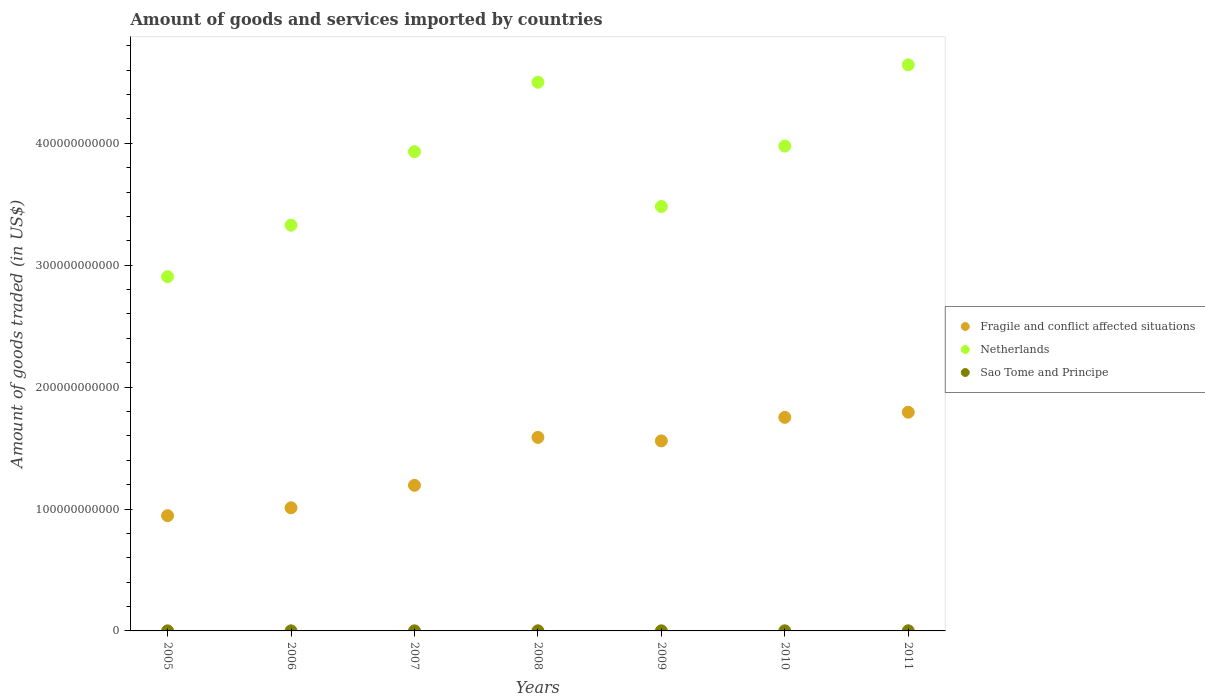Is the number of dotlines equal to the number of legend labels?
Your response must be concise. Yes. What is the total amount of goods and services imported in Fragile and conflict affected situations in 2008?
Ensure brevity in your answer.  1.59e+11. Across all years, what is the maximum total amount of goods and services imported in Netherlands?
Ensure brevity in your answer.  4.64e+11. Across all years, what is the minimum total amount of goods and services imported in Sao Tome and Principe?
Offer a terse response. 4.16e+07. What is the total total amount of goods and services imported in Sao Tome and Principe in the graph?
Provide a short and direct response. 5.54e+08. What is the difference between the total amount of goods and services imported in Sao Tome and Principe in 2008 and that in 2011?
Offer a very short reply. -2.35e+07. What is the difference between the total amount of goods and services imported in Fragile and conflict affected situations in 2009 and the total amount of goods and services imported in Sao Tome and Principe in 2007?
Make the answer very short. 1.56e+11. What is the average total amount of goods and services imported in Netherlands per year?
Give a very brief answer. 3.82e+11. In the year 2005, what is the difference between the total amount of goods and services imported in Fragile and conflict affected situations and total amount of goods and services imported in Sao Tome and Principe?
Keep it short and to the point. 9.45e+1. In how many years, is the total amount of goods and services imported in Fragile and conflict affected situations greater than 200000000000 US$?
Offer a terse response. 0. What is the ratio of the total amount of goods and services imported in Fragile and conflict affected situations in 2009 to that in 2011?
Ensure brevity in your answer.  0.87. Is the difference between the total amount of goods and services imported in Fragile and conflict affected situations in 2006 and 2010 greater than the difference between the total amount of goods and services imported in Sao Tome and Principe in 2006 and 2010?
Provide a short and direct response. No. What is the difference between the highest and the second highest total amount of goods and services imported in Netherlands?
Your answer should be compact. 1.42e+1. What is the difference between the highest and the lowest total amount of goods and services imported in Fragile and conflict affected situations?
Make the answer very short. 8.49e+1. Is the total amount of goods and services imported in Netherlands strictly greater than the total amount of goods and services imported in Fragile and conflict affected situations over the years?
Offer a terse response. Yes. What is the difference between two consecutive major ticks on the Y-axis?
Your answer should be compact. 1.00e+11. Does the graph contain grids?
Make the answer very short. No. Where does the legend appear in the graph?
Your answer should be compact. Center right. How many legend labels are there?
Offer a very short reply. 3. What is the title of the graph?
Offer a very short reply. Amount of goods and services imported by countries. Does "South Asia" appear as one of the legend labels in the graph?
Your response must be concise. No. What is the label or title of the X-axis?
Your response must be concise. Years. What is the label or title of the Y-axis?
Provide a succinct answer. Amount of goods traded (in US$). What is the Amount of goods traded (in US$) of Fragile and conflict affected situations in 2005?
Provide a succinct answer. 9.45e+1. What is the Amount of goods traded (in US$) in Netherlands in 2005?
Keep it short and to the point. 2.91e+11. What is the Amount of goods traded (in US$) in Sao Tome and Principe in 2005?
Your answer should be very brief. 4.16e+07. What is the Amount of goods traded (in US$) of Fragile and conflict affected situations in 2006?
Your answer should be compact. 1.01e+11. What is the Amount of goods traded (in US$) of Netherlands in 2006?
Offer a very short reply. 3.33e+11. What is the Amount of goods traded (in US$) in Sao Tome and Principe in 2006?
Ensure brevity in your answer.  5.92e+07. What is the Amount of goods traded (in US$) of Fragile and conflict affected situations in 2007?
Provide a short and direct response. 1.19e+11. What is the Amount of goods traded (in US$) in Netherlands in 2007?
Provide a short and direct response. 3.93e+11. What is the Amount of goods traded (in US$) in Sao Tome and Principe in 2007?
Keep it short and to the point. 6.49e+07. What is the Amount of goods traded (in US$) of Fragile and conflict affected situations in 2008?
Your answer should be very brief. 1.59e+11. What is the Amount of goods traded (in US$) of Netherlands in 2008?
Your answer should be compact. 4.50e+11. What is the Amount of goods traded (in US$) of Sao Tome and Principe in 2008?
Make the answer very short. 9.22e+07. What is the Amount of goods traded (in US$) in Fragile and conflict affected situations in 2009?
Offer a very short reply. 1.56e+11. What is the Amount of goods traded (in US$) in Netherlands in 2009?
Make the answer very short. 3.48e+11. What is the Amount of goods traded (in US$) in Sao Tome and Principe in 2009?
Your response must be concise. 8.38e+07. What is the Amount of goods traded (in US$) in Fragile and conflict affected situations in 2010?
Provide a succinct answer. 1.75e+11. What is the Amount of goods traded (in US$) of Netherlands in 2010?
Make the answer very short. 3.98e+11. What is the Amount of goods traded (in US$) of Sao Tome and Principe in 2010?
Ensure brevity in your answer.  9.62e+07. What is the Amount of goods traded (in US$) in Fragile and conflict affected situations in 2011?
Your answer should be compact. 1.79e+11. What is the Amount of goods traded (in US$) in Netherlands in 2011?
Your response must be concise. 4.64e+11. What is the Amount of goods traded (in US$) of Sao Tome and Principe in 2011?
Ensure brevity in your answer.  1.16e+08. Across all years, what is the maximum Amount of goods traded (in US$) in Fragile and conflict affected situations?
Give a very brief answer. 1.79e+11. Across all years, what is the maximum Amount of goods traded (in US$) in Netherlands?
Offer a terse response. 4.64e+11. Across all years, what is the maximum Amount of goods traded (in US$) in Sao Tome and Principe?
Provide a short and direct response. 1.16e+08. Across all years, what is the minimum Amount of goods traded (in US$) of Fragile and conflict affected situations?
Provide a short and direct response. 9.45e+1. Across all years, what is the minimum Amount of goods traded (in US$) of Netherlands?
Provide a short and direct response. 2.91e+11. Across all years, what is the minimum Amount of goods traded (in US$) of Sao Tome and Principe?
Make the answer very short. 4.16e+07. What is the total Amount of goods traded (in US$) of Fragile and conflict affected situations in the graph?
Provide a succinct answer. 9.84e+11. What is the total Amount of goods traded (in US$) of Netherlands in the graph?
Your answer should be very brief. 2.68e+12. What is the total Amount of goods traded (in US$) in Sao Tome and Principe in the graph?
Make the answer very short. 5.54e+08. What is the difference between the Amount of goods traded (in US$) of Fragile and conflict affected situations in 2005 and that in 2006?
Provide a short and direct response. -6.45e+09. What is the difference between the Amount of goods traded (in US$) of Netherlands in 2005 and that in 2006?
Your response must be concise. -4.23e+1. What is the difference between the Amount of goods traded (in US$) in Sao Tome and Principe in 2005 and that in 2006?
Offer a terse response. -1.76e+07. What is the difference between the Amount of goods traded (in US$) of Fragile and conflict affected situations in 2005 and that in 2007?
Offer a very short reply. -2.49e+1. What is the difference between the Amount of goods traded (in US$) in Netherlands in 2005 and that in 2007?
Give a very brief answer. -1.03e+11. What is the difference between the Amount of goods traded (in US$) of Sao Tome and Principe in 2005 and that in 2007?
Your answer should be very brief. -2.33e+07. What is the difference between the Amount of goods traded (in US$) of Fragile and conflict affected situations in 2005 and that in 2008?
Ensure brevity in your answer.  -6.42e+1. What is the difference between the Amount of goods traded (in US$) in Netherlands in 2005 and that in 2008?
Provide a short and direct response. -1.60e+11. What is the difference between the Amount of goods traded (in US$) in Sao Tome and Principe in 2005 and that in 2008?
Your response must be concise. -5.06e+07. What is the difference between the Amount of goods traded (in US$) in Fragile and conflict affected situations in 2005 and that in 2009?
Offer a very short reply. -6.14e+1. What is the difference between the Amount of goods traded (in US$) of Netherlands in 2005 and that in 2009?
Provide a succinct answer. -5.76e+1. What is the difference between the Amount of goods traded (in US$) in Sao Tome and Principe in 2005 and that in 2009?
Keep it short and to the point. -4.22e+07. What is the difference between the Amount of goods traded (in US$) in Fragile and conflict affected situations in 2005 and that in 2010?
Your answer should be very brief. -8.07e+1. What is the difference between the Amount of goods traded (in US$) in Netherlands in 2005 and that in 2010?
Make the answer very short. -1.07e+11. What is the difference between the Amount of goods traded (in US$) in Sao Tome and Principe in 2005 and that in 2010?
Provide a short and direct response. -5.46e+07. What is the difference between the Amount of goods traded (in US$) of Fragile and conflict affected situations in 2005 and that in 2011?
Provide a short and direct response. -8.49e+1. What is the difference between the Amount of goods traded (in US$) of Netherlands in 2005 and that in 2011?
Offer a very short reply. -1.74e+11. What is the difference between the Amount of goods traded (in US$) in Sao Tome and Principe in 2005 and that in 2011?
Your answer should be very brief. -7.41e+07. What is the difference between the Amount of goods traded (in US$) in Fragile and conflict affected situations in 2006 and that in 2007?
Provide a succinct answer. -1.84e+1. What is the difference between the Amount of goods traded (in US$) of Netherlands in 2006 and that in 2007?
Offer a terse response. -6.03e+1. What is the difference between the Amount of goods traded (in US$) in Sao Tome and Principe in 2006 and that in 2007?
Your answer should be very brief. -5.63e+06. What is the difference between the Amount of goods traded (in US$) of Fragile and conflict affected situations in 2006 and that in 2008?
Keep it short and to the point. -5.78e+1. What is the difference between the Amount of goods traded (in US$) in Netherlands in 2006 and that in 2008?
Keep it short and to the point. -1.17e+11. What is the difference between the Amount of goods traded (in US$) in Sao Tome and Principe in 2006 and that in 2008?
Provide a succinct answer. -3.29e+07. What is the difference between the Amount of goods traded (in US$) of Fragile and conflict affected situations in 2006 and that in 2009?
Provide a short and direct response. -5.49e+1. What is the difference between the Amount of goods traded (in US$) in Netherlands in 2006 and that in 2009?
Offer a very short reply. -1.53e+1. What is the difference between the Amount of goods traded (in US$) in Sao Tome and Principe in 2006 and that in 2009?
Your answer should be very brief. -2.45e+07. What is the difference between the Amount of goods traded (in US$) in Fragile and conflict affected situations in 2006 and that in 2010?
Your answer should be compact. -7.42e+1. What is the difference between the Amount of goods traded (in US$) in Netherlands in 2006 and that in 2010?
Provide a succinct answer. -6.49e+1. What is the difference between the Amount of goods traded (in US$) in Sao Tome and Principe in 2006 and that in 2010?
Give a very brief answer. -3.70e+07. What is the difference between the Amount of goods traded (in US$) in Fragile and conflict affected situations in 2006 and that in 2011?
Ensure brevity in your answer.  -7.84e+1. What is the difference between the Amount of goods traded (in US$) of Netherlands in 2006 and that in 2011?
Offer a terse response. -1.32e+11. What is the difference between the Amount of goods traded (in US$) of Sao Tome and Principe in 2006 and that in 2011?
Offer a very short reply. -5.64e+07. What is the difference between the Amount of goods traded (in US$) in Fragile and conflict affected situations in 2007 and that in 2008?
Ensure brevity in your answer.  -3.93e+1. What is the difference between the Amount of goods traded (in US$) in Netherlands in 2007 and that in 2008?
Offer a terse response. -5.70e+1. What is the difference between the Amount of goods traded (in US$) of Sao Tome and Principe in 2007 and that in 2008?
Your answer should be very brief. -2.73e+07. What is the difference between the Amount of goods traded (in US$) in Fragile and conflict affected situations in 2007 and that in 2009?
Provide a short and direct response. -3.65e+1. What is the difference between the Amount of goods traded (in US$) of Netherlands in 2007 and that in 2009?
Offer a terse response. 4.50e+1. What is the difference between the Amount of goods traded (in US$) of Sao Tome and Principe in 2007 and that in 2009?
Make the answer very short. -1.89e+07. What is the difference between the Amount of goods traded (in US$) of Fragile and conflict affected situations in 2007 and that in 2010?
Keep it short and to the point. -5.58e+1. What is the difference between the Amount of goods traded (in US$) in Netherlands in 2007 and that in 2010?
Your response must be concise. -4.58e+09. What is the difference between the Amount of goods traded (in US$) of Sao Tome and Principe in 2007 and that in 2010?
Ensure brevity in your answer.  -3.13e+07. What is the difference between the Amount of goods traded (in US$) of Fragile and conflict affected situations in 2007 and that in 2011?
Ensure brevity in your answer.  -6.00e+1. What is the difference between the Amount of goods traded (in US$) of Netherlands in 2007 and that in 2011?
Give a very brief answer. -7.12e+1. What is the difference between the Amount of goods traded (in US$) of Sao Tome and Principe in 2007 and that in 2011?
Ensure brevity in your answer.  -5.08e+07. What is the difference between the Amount of goods traded (in US$) of Fragile and conflict affected situations in 2008 and that in 2009?
Offer a terse response. 2.86e+09. What is the difference between the Amount of goods traded (in US$) in Netherlands in 2008 and that in 2009?
Provide a short and direct response. 1.02e+11. What is the difference between the Amount of goods traded (in US$) of Sao Tome and Principe in 2008 and that in 2009?
Your response must be concise. 8.39e+06. What is the difference between the Amount of goods traded (in US$) of Fragile and conflict affected situations in 2008 and that in 2010?
Offer a terse response. -1.64e+1. What is the difference between the Amount of goods traded (in US$) in Netherlands in 2008 and that in 2010?
Make the answer very short. 5.24e+1. What is the difference between the Amount of goods traded (in US$) of Sao Tome and Principe in 2008 and that in 2010?
Your answer should be very brief. -4.04e+06. What is the difference between the Amount of goods traded (in US$) of Fragile and conflict affected situations in 2008 and that in 2011?
Offer a terse response. -2.06e+1. What is the difference between the Amount of goods traded (in US$) in Netherlands in 2008 and that in 2011?
Give a very brief answer. -1.42e+1. What is the difference between the Amount of goods traded (in US$) of Sao Tome and Principe in 2008 and that in 2011?
Provide a short and direct response. -2.35e+07. What is the difference between the Amount of goods traded (in US$) of Fragile and conflict affected situations in 2009 and that in 2010?
Keep it short and to the point. -1.93e+1. What is the difference between the Amount of goods traded (in US$) in Netherlands in 2009 and that in 2010?
Provide a succinct answer. -4.96e+1. What is the difference between the Amount of goods traded (in US$) of Sao Tome and Principe in 2009 and that in 2010?
Your answer should be very brief. -1.24e+07. What is the difference between the Amount of goods traded (in US$) in Fragile and conflict affected situations in 2009 and that in 2011?
Offer a terse response. -2.35e+1. What is the difference between the Amount of goods traded (in US$) of Netherlands in 2009 and that in 2011?
Offer a very short reply. -1.16e+11. What is the difference between the Amount of goods traded (in US$) in Sao Tome and Principe in 2009 and that in 2011?
Provide a succinct answer. -3.19e+07. What is the difference between the Amount of goods traded (in US$) in Fragile and conflict affected situations in 2010 and that in 2011?
Make the answer very short. -4.21e+09. What is the difference between the Amount of goods traded (in US$) in Netherlands in 2010 and that in 2011?
Offer a very short reply. -6.66e+1. What is the difference between the Amount of goods traded (in US$) in Sao Tome and Principe in 2010 and that in 2011?
Keep it short and to the point. -1.95e+07. What is the difference between the Amount of goods traded (in US$) of Fragile and conflict affected situations in 2005 and the Amount of goods traded (in US$) of Netherlands in 2006?
Provide a succinct answer. -2.38e+11. What is the difference between the Amount of goods traded (in US$) of Fragile and conflict affected situations in 2005 and the Amount of goods traded (in US$) of Sao Tome and Principe in 2006?
Ensure brevity in your answer.  9.45e+1. What is the difference between the Amount of goods traded (in US$) in Netherlands in 2005 and the Amount of goods traded (in US$) in Sao Tome and Principe in 2006?
Your response must be concise. 2.91e+11. What is the difference between the Amount of goods traded (in US$) of Fragile and conflict affected situations in 2005 and the Amount of goods traded (in US$) of Netherlands in 2007?
Provide a short and direct response. -2.99e+11. What is the difference between the Amount of goods traded (in US$) in Fragile and conflict affected situations in 2005 and the Amount of goods traded (in US$) in Sao Tome and Principe in 2007?
Provide a succinct answer. 9.45e+1. What is the difference between the Amount of goods traded (in US$) in Netherlands in 2005 and the Amount of goods traded (in US$) in Sao Tome and Principe in 2007?
Make the answer very short. 2.91e+11. What is the difference between the Amount of goods traded (in US$) in Fragile and conflict affected situations in 2005 and the Amount of goods traded (in US$) in Netherlands in 2008?
Offer a very short reply. -3.56e+11. What is the difference between the Amount of goods traded (in US$) of Fragile and conflict affected situations in 2005 and the Amount of goods traded (in US$) of Sao Tome and Principe in 2008?
Offer a very short reply. 9.44e+1. What is the difference between the Amount of goods traded (in US$) of Netherlands in 2005 and the Amount of goods traded (in US$) of Sao Tome and Principe in 2008?
Provide a succinct answer. 2.90e+11. What is the difference between the Amount of goods traded (in US$) of Fragile and conflict affected situations in 2005 and the Amount of goods traded (in US$) of Netherlands in 2009?
Provide a short and direct response. -2.54e+11. What is the difference between the Amount of goods traded (in US$) in Fragile and conflict affected situations in 2005 and the Amount of goods traded (in US$) in Sao Tome and Principe in 2009?
Give a very brief answer. 9.45e+1. What is the difference between the Amount of goods traded (in US$) in Netherlands in 2005 and the Amount of goods traded (in US$) in Sao Tome and Principe in 2009?
Your answer should be compact. 2.90e+11. What is the difference between the Amount of goods traded (in US$) in Fragile and conflict affected situations in 2005 and the Amount of goods traded (in US$) in Netherlands in 2010?
Your answer should be compact. -3.03e+11. What is the difference between the Amount of goods traded (in US$) of Fragile and conflict affected situations in 2005 and the Amount of goods traded (in US$) of Sao Tome and Principe in 2010?
Ensure brevity in your answer.  9.44e+1. What is the difference between the Amount of goods traded (in US$) in Netherlands in 2005 and the Amount of goods traded (in US$) in Sao Tome and Principe in 2010?
Your answer should be compact. 2.90e+11. What is the difference between the Amount of goods traded (in US$) of Fragile and conflict affected situations in 2005 and the Amount of goods traded (in US$) of Netherlands in 2011?
Make the answer very short. -3.70e+11. What is the difference between the Amount of goods traded (in US$) of Fragile and conflict affected situations in 2005 and the Amount of goods traded (in US$) of Sao Tome and Principe in 2011?
Offer a terse response. 9.44e+1. What is the difference between the Amount of goods traded (in US$) of Netherlands in 2005 and the Amount of goods traded (in US$) of Sao Tome and Principe in 2011?
Keep it short and to the point. 2.90e+11. What is the difference between the Amount of goods traded (in US$) of Fragile and conflict affected situations in 2006 and the Amount of goods traded (in US$) of Netherlands in 2007?
Give a very brief answer. -2.92e+11. What is the difference between the Amount of goods traded (in US$) in Fragile and conflict affected situations in 2006 and the Amount of goods traded (in US$) in Sao Tome and Principe in 2007?
Make the answer very short. 1.01e+11. What is the difference between the Amount of goods traded (in US$) of Netherlands in 2006 and the Amount of goods traded (in US$) of Sao Tome and Principe in 2007?
Offer a terse response. 3.33e+11. What is the difference between the Amount of goods traded (in US$) of Fragile and conflict affected situations in 2006 and the Amount of goods traded (in US$) of Netherlands in 2008?
Keep it short and to the point. -3.49e+11. What is the difference between the Amount of goods traded (in US$) of Fragile and conflict affected situations in 2006 and the Amount of goods traded (in US$) of Sao Tome and Principe in 2008?
Ensure brevity in your answer.  1.01e+11. What is the difference between the Amount of goods traded (in US$) in Netherlands in 2006 and the Amount of goods traded (in US$) in Sao Tome and Principe in 2008?
Your answer should be very brief. 3.33e+11. What is the difference between the Amount of goods traded (in US$) in Fragile and conflict affected situations in 2006 and the Amount of goods traded (in US$) in Netherlands in 2009?
Give a very brief answer. -2.47e+11. What is the difference between the Amount of goods traded (in US$) of Fragile and conflict affected situations in 2006 and the Amount of goods traded (in US$) of Sao Tome and Principe in 2009?
Your response must be concise. 1.01e+11. What is the difference between the Amount of goods traded (in US$) of Netherlands in 2006 and the Amount of goods traded (in US$) of Sao Tome and Principe in 2009?
Your response must be concise. 3.33e+11. What is the difference between the Amount of goods traded (in US$) in Fragile and conflict affected situations in 2006 and the Amount of goods traded (in US$) in Netherlands in 2010?
Provide a short and direct response. -2.97e+11. What is the difference between the Amount of goods traded (in US$) of Fragile and conflict affected situations in 2006 and the Amount of goods traded (in US$) of Sao Tome and Principe in 2010?
Provide a succinct answer. 1.01e+11. What is the difference between the Amount of goods traded (in US$) of Netherlands in 2006 and the Amount of goods traded (in US$) of Sao Tome and Principe in 2010?
Provide a succinct answer. 3.33e+11. What is the difference between the Amount of goods traded (in US$) of Fragile and conflict affected situations in 2006 and the Amount of goods traded (in US$) of Netherlands in 2011?
Provide a short and direct response. -3.63e+11. What is the difference between the Amount of goods traded (in US$) of Fragile and conflict affected situations in 2006 and the Amount of goods traded (in US$) of Sao Tome and Principe in 2011?
Give a very brief answer. 1.01e+11. What is the difference between the Amount of goods traded (in US$) in Netherlands in 2006 and the Amount of goods traded (in US$) in Sao Tome and Principe in 2011?
Your answer should be compact. 3.33e+11. What is the difference between the Amount of goods traded (in US$) in Fragile and conflict affected situations in 2007 and the Amount of goods traded (in US$) in Netherlands in 2008?
Your answer should be very brief. -3.31e+11. What is the difference between the Amount of goods traded (in US$) in Fragile and conflict affected situations in 2007 and the Amount of goods traded (in US$) in Sao Tome and Principe in 2008?
Offer a very short reply. 1.19e+11. What is the difference between the Amount of goods traded (in US$) of Netherlands in 2007 and the Amount of goods traded (in US$) of Sao Tome and Principe in 2008?
Offer a terse response. 3.93e+11. What is the difference between the Amount of goods traded (in US$) of Fragile and conflict affected situations in 2007 and the Amount of goods traded (in US$) of Netherlands in 2009?
Offer a terse response. -2.29e+11. What is the difference between the Amount of goods traded (in US$) of Fragile and conflict affected situations in 2007 and the Amount of goods traded (in US$) of Sao Tome and Principe in 2009?
Provide a short and direct response. 1.19e+11. What is the difference between the Amount of goods traded (in US$) in Netherlands in 2007 and the Amount of goods traded (in US$) in Sao Tome and Principe in 2009?
Provide a short and direct response. 3.93e+11. What is the difference between the Amount of goods traded (in US$) in Fragile and conflict affected situations in 2007 and the Amount of goods traded (in US$) in Netherlands in 2010?
Give a very brief answer. -2.78e+11. What is the difference between the Amount of goods traded (in US$) of Fragile and conflict affected situations in 2007 and the Amount of goods traded (in US$) of Sao Tome and Principe in 2010?
Keep it short and to the point. 1.19e+11. What is the difference between the Amount of goods traded (in US$) in Netherlands in 2007 and the Amount of goods traded (in US$) in Sao Tome and Principe in 2010?
Offer a very short reply. 3.93e+11. What is the difference between the Amount of goods traded (in US$) in Fragile and conflict affected situations in 2007 and the Amount of goods traded (in US$) in Netherlands in 2011?
Give a very brief answer. -3.45e+11. What is the difference between the Amount of goods traded (in US$) in Fragile and conflict affected situations in 2007 and the Amount of goods traded (in US$) in Sao Tome and Principe in 2011?
Provide a succinct answer. 1.19e+11. What is the difference between the Amount of goods traded (in US$) of Netherlands in 2007 and the Amount of goods traded (in US$) of Sao Tome and Principe in 2011?
Provide a short and direct response. 3.93e+11. What is the difference between the Amount of goods traded (in US$) in Fragile and conflict affected situations in 2008 and the Amount of goods traded (in US$) in Netherlands in 2009?
Your answer should be very brief. -1.89e+11. What is the difference between the Amount of goods traded (in US$) in Fragile and conflict affected situations in 2008 and the Amount of goods traded (in US$) in Sao Tome and Principe in 2009?
Offer a very short reply. 1.59e+11. What is the difference between the Amount of goods traded (in US$) of Netherlands in 2008 and the Amount of goods traded (in US$) of Sao Tome and Principe in 2009?
Offer a terse response. 4.50e+11. What is the difference between the Amount of goods traded (in US$) of Fragile and conflict affected situations in 2008 and the Amount of goods traded (in US$) of Netherlands in 2010?
Give a very brief answer. -2.39e+11. What is the difference between the Amount of goods traded (in US$) of Fragile and conflict affected situations in 2008 and the Amount of goods traded (in US$) of Sao Tome and Principe in 2010?
Ensure brevity in your answer.  1.59e+11. What is the difference between the Amount of goods traded (in US$) of Netherlands in 2008 and the Amount of goods traded (in US$) of Sao Tome and Principe in 2010?
Keep it short and to the point. 4.50e+11. What is the difference between the Amount of goods traded (in US$) of Fragile and conflict affected situations in 2008 and the Amount of goods traded (in US$) of Netherlands in 2011?
Offer a very short reply. -3.06e+11. What is the difference between the Amount of goods traded (in US$) in Fragile and conflict affected situations in 2008 and the Amount of goods traded (in US$) in Sao Tome and Principe in 2011?
Your answer should be compact. 1.59e+11. What is the difference between the Amount of goods traded (in US$) of Netherlands in 2008 and the Amount of goods traded (in US$) of Sao Tome and Principe in 2011?
Make the answer very short. 4.50e+11. What is the difference between the Amount of goods traded (in US$) of Fragile and conflict affected situations in 2009 and the Amount of goods traded (in US$) of Netherlands in 2010?
Make the answer very short. -2.42e+11. What is the difference between the Amount of goods traded (in US$) of Fragile and conflict affected situations in 2009 and the Amount of goods traded (in US$) of Sao Tome and Principe in 2010?
Your response must be concise. 1.56e+11. What is the difference between the Amount of goods traded (in US$) in Netherlands in 2009 and the Amount of goods traded (in US$) in Sao Tome and Principe in 2010?
Make the answer very short. 3.48e+11. What is the difference between the Amount of goods traded (in US$) of Fragile and conflict affected situations in 2009 and the Amount of goods traded (in US$) of Netherlands in 2011?
Ensure brevity in your answer.  -3.08e+11. What is the difference between the Amount of goods traded (in US$) of Fragile and conflict affected situations in 2009 and the Amount of goods traded (in US$) of Sao Tome and Principe in 2011?
Keep it short and to the point. 1.56e+11. What is the difference between the Amount of goods traded (in US$) of Netherlands in 2009 and the Amount of goods traded (in US$) of Sao Tome and Principe in 2011?
Offer a very short reply. 3.48e+11. What is the difference between the Amount of goods traded (in US$) of Fragile and conflict affected situations in 2010 and the Amount of goods traded (in US$) of Netherlands in 2011?
Your answer should be very brief. -2.89e+11. What is the difference between the Amount of goods traded (in US$) of Fragile and conflict affected situations in 2010 and the Amount of goods traded (in US$) of Sao Tome and Principe in 2011?
Make the answer very short. 1.75e+11. What is the difference between the Amount of goods traded (in US$) in Netherlands in 2010 and the Amount of goods traded (in US$) in Sao Tome and Principe in 2011?
Provide a succinct answer. 3.98e+11. What is the average Amount of goods traded (in US$) in Fragile and conflict affected situations per year?
Provide a short and direct response. 1.41e+11. What is the average Amount of goods traded (in US$) in Netherlands per year?
Your answer should be compact. 3.82e+11. What is the average Amount of goods traded (in US$) of Sao Tome and Principe per year?
Your answer should be compact. 7.91e+07. In the year 2005, what is the difference between the Amount of goods traded (in US$) of Fragile and conflict affected situations and Amount of goods traded (in US$) of Netherlands?
Offer a very short reply. -1.96e+11. In the year 2005, what is the difference between the Amount of goods traded (in US$) of Fragile and conflict affected situations and Amount of goods traded (in US$) of Sao Tome and Principe?
Your answer should be compact. 9.45e+1. In the year 2005, what is the difference between the Amount of goods traded (in US$) of Netherlands and Amount of goods traded (in US$) of Sao Tome and Principe?
Make the answer very short. 2.91e+11. In the year 2006, what is the difference between the Amount of goods traded (in US$) in Fragile and conflict affected situations and Amount of goods traded (in US$) in Netherlands?
Give a very brief answer. -2.32e+11. In the year 2006, what is the difference between the Amount of goods traded (in US$) of Fragile and conflict affected situations and Amount of goods traded (in US$) of Sao Tome and Principe?
Make the answer very short. 1.01e+11. In the year 2006, what is the difference between the Amount of goods traded (in US$) in Netherlands and Amount of goods traded (in US$) in Sao Tome and Principe?
Your answer should be compact. 3.33e+11. In the year 2007, what is the difference between the Amount of goods traded (in US$) of Fragile and conflict affected situations and Amount of goods traded (in US$) of Netherlands?
Your response must be concise. -2.74e+11. In the year 2007, what is the difference between the Amount of goods traded (in US$) in Fragile and conflict affected situations and Amount of goods traded (in US$) in Sao Tome and Principe?
Your answer should be very brief. 1.19e+11. In the year 2007, what is the difference between the Amount of goods traded (in US$) in Netherlands and Amount of goods traded (in US$) in Sao Tome and Principe?
Make the answer very short. 3.93e+11. In the year 2008, what is the difference between the Amount of goods traded (in US$) of Fragile and conflict affected situations and Amount of goods traded (in US$) of Netherlands?
Offer a very short reply. -2.91e+11. In the year 2008, what is the difference between the Amount of goods traded (in US$) of Fragile and conflict affected situations and Amount of goods traded (in US$) of Sao Tome and Principe?
Provide a succinct answer. 1.59e+11. In the year 2008, what is the difference between the Amount of goods traded (in US$) of Netherlands and Amount of goods traded (in US$) of Sao Tome and Principe?
Your answer should be very brief. 4.50e+11. In the year 2009, what is the difference between the Amount of goods traded (in US$) in Fragile and conflict affected situations and Amount of goods traded (in US$) in Netherlands?
Ensure brevity in your answer.  -1.92e+11. In the year 2009, what is the difference between the Amount of goods traded (in US$) of Fragile and conflict affected situations and Amount of goods traded (in US$) of Sao Tome and Principe?
Your answer should be compact. 1.56e+11. In the year 2009, what is the difference between the Amount of goods traded (in US$) of Netherlands and Amount of goods traded (in US$) of Sao Tome and Principe?
Provide a succinct answer. 3.48e+11. In the year 2010, what is the difference between the Amount of goods traded (in US$) of Fragile and conflict affected situations and Amount of goods traded (in US$) of Netherlands?
Your answer should be very brief. -2.23e+11. In the year 2010, what is the difference between the Amount of goods traded (in US$) in Fragile and conflict affected situations and Amount of goods traded (in US$) in Sao Tome and Principe?
Ensure brevity in your answer.  1.75e+11. In the year 2010, what is the difference between the Amount of goods traded (in US$) of Netherlands and Amount of goods traded (in US$) of Sao Tome and Principe?
Provide a succinct answer. 3.98e+11. In the year 2011, what is the difference between the Amount of goods traded (in US$) in Fragile and conflict affected situations and Amount of goods traded (in US$) in Netherlands?
Offer a very short reply. -2.85e+11. In the year 2011, what is the difference between the Amount of goods traded (in US$) in Fragile and conflict affected situations and Amount of goods traded (in US$) in Sao Tome and Principe?
Your response must be concise. 1.79e+11. In the year 2011, what is the difference between the Amount of goods traded (in US$) in Netherlands and Amount of goods traded (in US$) in Sao Tome and Principe?
Your response must be concise. 4.64e+11. What is the ratio of the Amount of goods traded (in US$) of Fragile and conflict affected situations in 2005 to that in 2006?
Offer a terse response. 0.94. What is the ratio of the Amount of goods traded (in US$) in Netherlands in 2005 to that in 2006?
Offer a very short reply. 0.87. What is the ratio of the Amount of goods traded (in US$) of Sao Tome and Principe in 2005 to that in 2006?
Offer a very short reply. 0.7. What is the ratio of the Amount of goods traded (in US$) in Fragile and conflict affected situations in 2005 to that in 2007?
Give a very brief answer. 0.79. What is the ratio of the Amount of goods traded (in US$) in Netherlands in 2005 to that in 2007?
Your answer should be compact. 0.74. What is the ratio of the Amount of goods traded (in US$) of Sao Tome and Principe in 2005 to that in 2007?
Make the answer very short. 0.64. What is the ratio of the Amount of goods traded (in US$) in Fragile and conflict affected situations in 2005 to that in 2008?
Give a very brief answer. 0.6. What is the ratio of the Amount of goods traded (in US$) of Netherlands in 2005 to that in 2008?
Provide a short and direct response. 0.65. What is the ratio of the Amount of goods traded (in US$) in Sao Tome and Principe in 2005 to that in 2008?
Make the answer very short. 0.45. What is the ratio of the Amount of goods traded (in US$) of Fragile and conflict affected situations in 2005 to that in 2009?
Make the answer very short. 0.61. What is the ratio of the Amount of goods traded (in US$) in Netherlands in 2005 to that in 2009?
Your response must be concise. 0.83. What is the ratio of the Amount of goods traded (in US$) in Sao Tome and Principe in 2005 to that in 2009?
Provide a short and direct response. 0.5. What is the ratio of the Amount of goods traded (in US$) of Fragile and conflict affected situations in 2005 to that in 2010?
Ensure brevity in your answer.  0.54. What is the ratio of the Amount of goods traded (in US$) in Netherlands in 2005 to that in 2010?
Offer a very short reply. 0.73. What is the ratio of the Amount of goods traded (in US$) in Sao Tome and Principe in 2005 to that in 2010?
Provide a succinct answer. 0.43. What is the ratio of the Amount of goods traded (in US$) of Fragile and conflict affected situations in 2005 to that in 2011?
Give a very brief answer. 0.53. What is the ratio of the Amount of goods traded (in US$) of Netherlands in 2005 to that in 2011?
Provide a succinct answer. 0.63. What is the ratio of the Amount of goods traded (in US$) of Sao Tome and Principe in 2005 to that in 2011?
Your answer should be compact. 0.36. What is the ratio of the Amount of goods traded (in US$) of Fragile and conflict affected situations in 2006 to that in 2007?
Offer a terse response. 0.85. What is the ratio of the Amount of goods traded (in US$) of Netherlands in 2006 to that in 2007?
Provide a succinct answer. 0.85. What is the ratio of the Amount of goods traded (in US$) in Sao Tome and Principe in 2006 to that in 2007?
Your response must be concise. 0.91. What is the ratio of the Amount of goods traded (in US$) of Fragile and conflict affected situations in 2006 to that in 2008?
Keep it short and to the point. 0.64. What is the ratio of the Amount of goods traded (in US$) of Netherlands in 2006 to that in 2008?
Provide a short and direct response. 0.74. What is the ratio of the Amount of goods traded (in US$) of Sao Tome and Principe in 2006 to that in 2008?
Your response must be concise. 0.64. What is the ratio of the Amount of goods traded (in US$) of Fragile and conflict affected situations in 2006 to that in 2009?
Provide a short and direct response. 0.65. What is the ratio of the Amount of goods traded (in US$) in Netherlands in 2006 to that in 2009?
Keep it short and to the point. 0.96. What is the ratio of the Amount of goods traded (in US$) in Sao Tome and Principe in 2006 to that in 2009?
Your answer should be very brief. 0.71. What is the ratio of the Amount of goods traded (in US$) of Fragile and conflict affected situations in 2006 to that in 2010?
Your answer should be compact. 0.58. What is the ratio of the Amount of goods traded (in US$) in Netherlands in 2006 to that in 2010?
Make the answer very short. 0.84. What is the ratio of the Amount of goods traded (in US$) in Sao Tome and Principe in 2006 to that in 2010?
Offer a very short reply. 0.62. What is the ratio of the Amount of goods traded (in US$) in Fragile and conflict affected situations in 2006 to that in 2011?
Your answer should be compact. 0.56. What is the ratio of the Amount of goods traded (in US$) of Netherlands in 2006 to that in 2011?
Your response must be concise. 0.72. What is the ratio of the Amount of goods traded (in US$) of Sao Tome and Principe in 2006 to that in 2011?
Give a very brief answer. 0.51. What is the ratio of the Amount of goods traded (in US$) in Fragile and conflict affected situations in 2007 to that in 2008?
Provide a succinct answer. 0.75. What is the ratio of the Amount of goods traded (in US$) of Netherlands in 2007 to that in 2008?
Provide a short and direct response. 0.87. What is the ratio of the Amount of goods traded (in US$) of Sao Tome and Principe in 2007 to that in 2008?
Give a very brief answer. 0.7. What is the ratio of the Amount of goods traded (in US$) in Fragile and conflict affected situations in 2007 to that in 2009?
Provide a succinct answer. 0.77. What is the ratio of the Amount of goods traded (in US$) in Netherlands in 2007 to that in 2009?
Keep it short and to the point. 1.13. What is the ratio of the Amount of goods traded (in US$) in Sao Tome and Principe in 2007 to that in 2009?
Make the answer very short. 0.77. What is the ratio of the Amount of goods traded (in US$) of Fragile and conflict affected situations in 2007 to that in 2010?
Ensure brevity in your answer.  0.68. What is the ratio of the Amount of goods traded (in US$) in Netherlands in 2007 to that in 2010?
Make the answer very short. 0.99. What is the ratio of the Amount of goods traded (in US$) in Sao Tome and Principe in 2007 to that in 2010?
Your answer should be very brief. 0.67. What is the ratio of the Amount of goods traded (in US$) of Fragile and conflict affected situations in 2007 to that in 2011?
Your answer should be compact. 0.67. What is the ratio of the Amount of goods traded (in US$) in Netherlands in 2007 to that in 2011?
Provide a short and direct response. 0.85. What is the ratio of the Amount of goods traded (in US$) of Sao Tome and Principe in 2007 to that in 2011?
Offer a terse response. 0.56. What is the ratio of the Amount of goods traded (in US$) of Fragile and conflict affected situations in 2008 to that in 2009?
Ensure brevity in your answer.  1.02. What is the ratio of the Amount of goods traded (in US$) of Netherlands in 2008 to that in 2009?
Offer a terse response. 1.29. What is the ratio of the Amount of goods traded (in US$) of Sao Tome and Principe in 2008 to that in 2009?
Offer a very short reply. 1.1. What is the ratio of the Amount of goods traded (in US$) in Fragile and conflict affected situations in 2008 to that in 2010?
Make the answer very short. 0.91. What is the ratio of the Amount of goods traded (in US$) of Netherlands in 2008 to that in 2010?
Your response must be concise. 1.13. What is the ratio of the Amount of goods traded (in US$) in Sao Tome and Principe in 2008 to that in 2010?
Keep it short and to the point. 0.96. What is the ratio of the Amount of goods traded (in US$) of Fragile and conflict affected situations in 2008 to that in 2011?
Your answer should be very brief. 0.88. What is the ratio of the Amount of goods traded (in US$) of Netherlands in 2008 to that in 2011?
Make the answer very short. 0.97. What is the ratio of the Amount of goods traded (in US$) in Sao Tome and Principe in 2008 to that in 2011?
Provide a succinct answer. 0.8. What is the ratio of the Amount of goods traded (in US$) of Fragile and conflict affected situations in 2009 to that in 2010?
Make the answer very short. 0.89. What is the ratio of the Amount of goods traded (in US$) of Netherlands in 2009 to that in 2010?
Your answer should be compact. 0.88. What is the ratio of the Amount of goods traded (in US$) of Sao Tome and Principe in 2009 to that in 2010?
Your answer should be compact. 0.87. What is the ratio of the Amount of goods traded (in US$) in Fragile and conflict affected situations in 2009 to that in 2011?
Make the answer very short. 0.87. What is the ratio of the Amount of goods traded (in US$) of Netherlands in 2009 to that in 2011?
Make the answer very short. 0.75. What is the ratio of the Amount of goods traded (in US$) of Sao Tome and Principe in 2009 to that in 2011?
Ensure brevity in your answer.  0.72. What is the ratio of the Amount of goods traded (in US$) in Fragile and conflict affected situations in 2010 to that in 2011?
Your response must be concise. 0.98. What is the ratio of the Amount of goods traded (in US$) in Netherlands in 2010 to that in 2011?
Offer a terse response. 0.86. What is the ratio of the Amount of goods traded (in US$) of Sao Tome and Principe in 2010 to that in 2011?
Provide a succinct answer. 0.83. What is the difference between the highest and the second highest Amount of goods traded (in US$) of Fragile and conflict affected situations?
Your response must be concise. 4.21e+09. What is the difference between the highest and the second highest Amount of goods traded (in US$) in Netherlands?
Provide a succinct answer. 1.42e+1. What is the difference between the highest and the second highest Amount of goods traded (in US$) in Sao Tome and Principe?
Ensure brevity in your answer.  1.95e+07. What is the difference between the highest and the lowest Amount of goods traded (in US$) in Fragile and conflict affected situations?
Ensure brevity in your answer.  8.49e+1. What is the difference between the highest and the lowest Amount of goods traded (in US$) of Netherlands?
Provide a succinct answer. 1.74e+11. What is the difference between the highest and the lowest Amount of goods traded (in US$) in Sao Tome and Principe?
Give a very brief answer. 7.41e+07. 